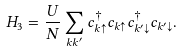<formula> <loc_0><loc_0><loc_500><loc_500>H _ { 3 } = \frac { U } { N } \sum _ { k k ^ { \prime } } c ^ { \dag } _ { k \uparrow } c _ { k \uparrow } c ^ { \dag } _ { k ^ { \prime } \downarrow } c _ { k ^ { \prime } \downarrow } .</formula> 